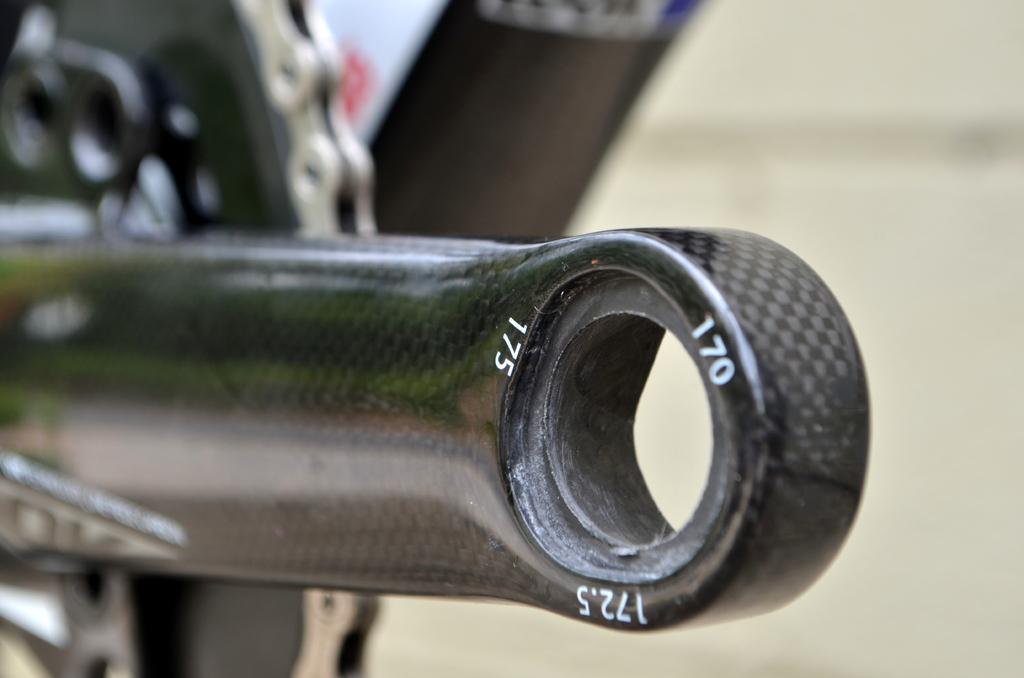What objects related to a bicycle can be seen in the image? There are parts of a bicycle in the image. Can you describe the background of the image? The background of the image is blurry. What type of powder is being used by the band in the image? There is no band or powder present in the image; it only features parts of a bicycle and a blurry background. 